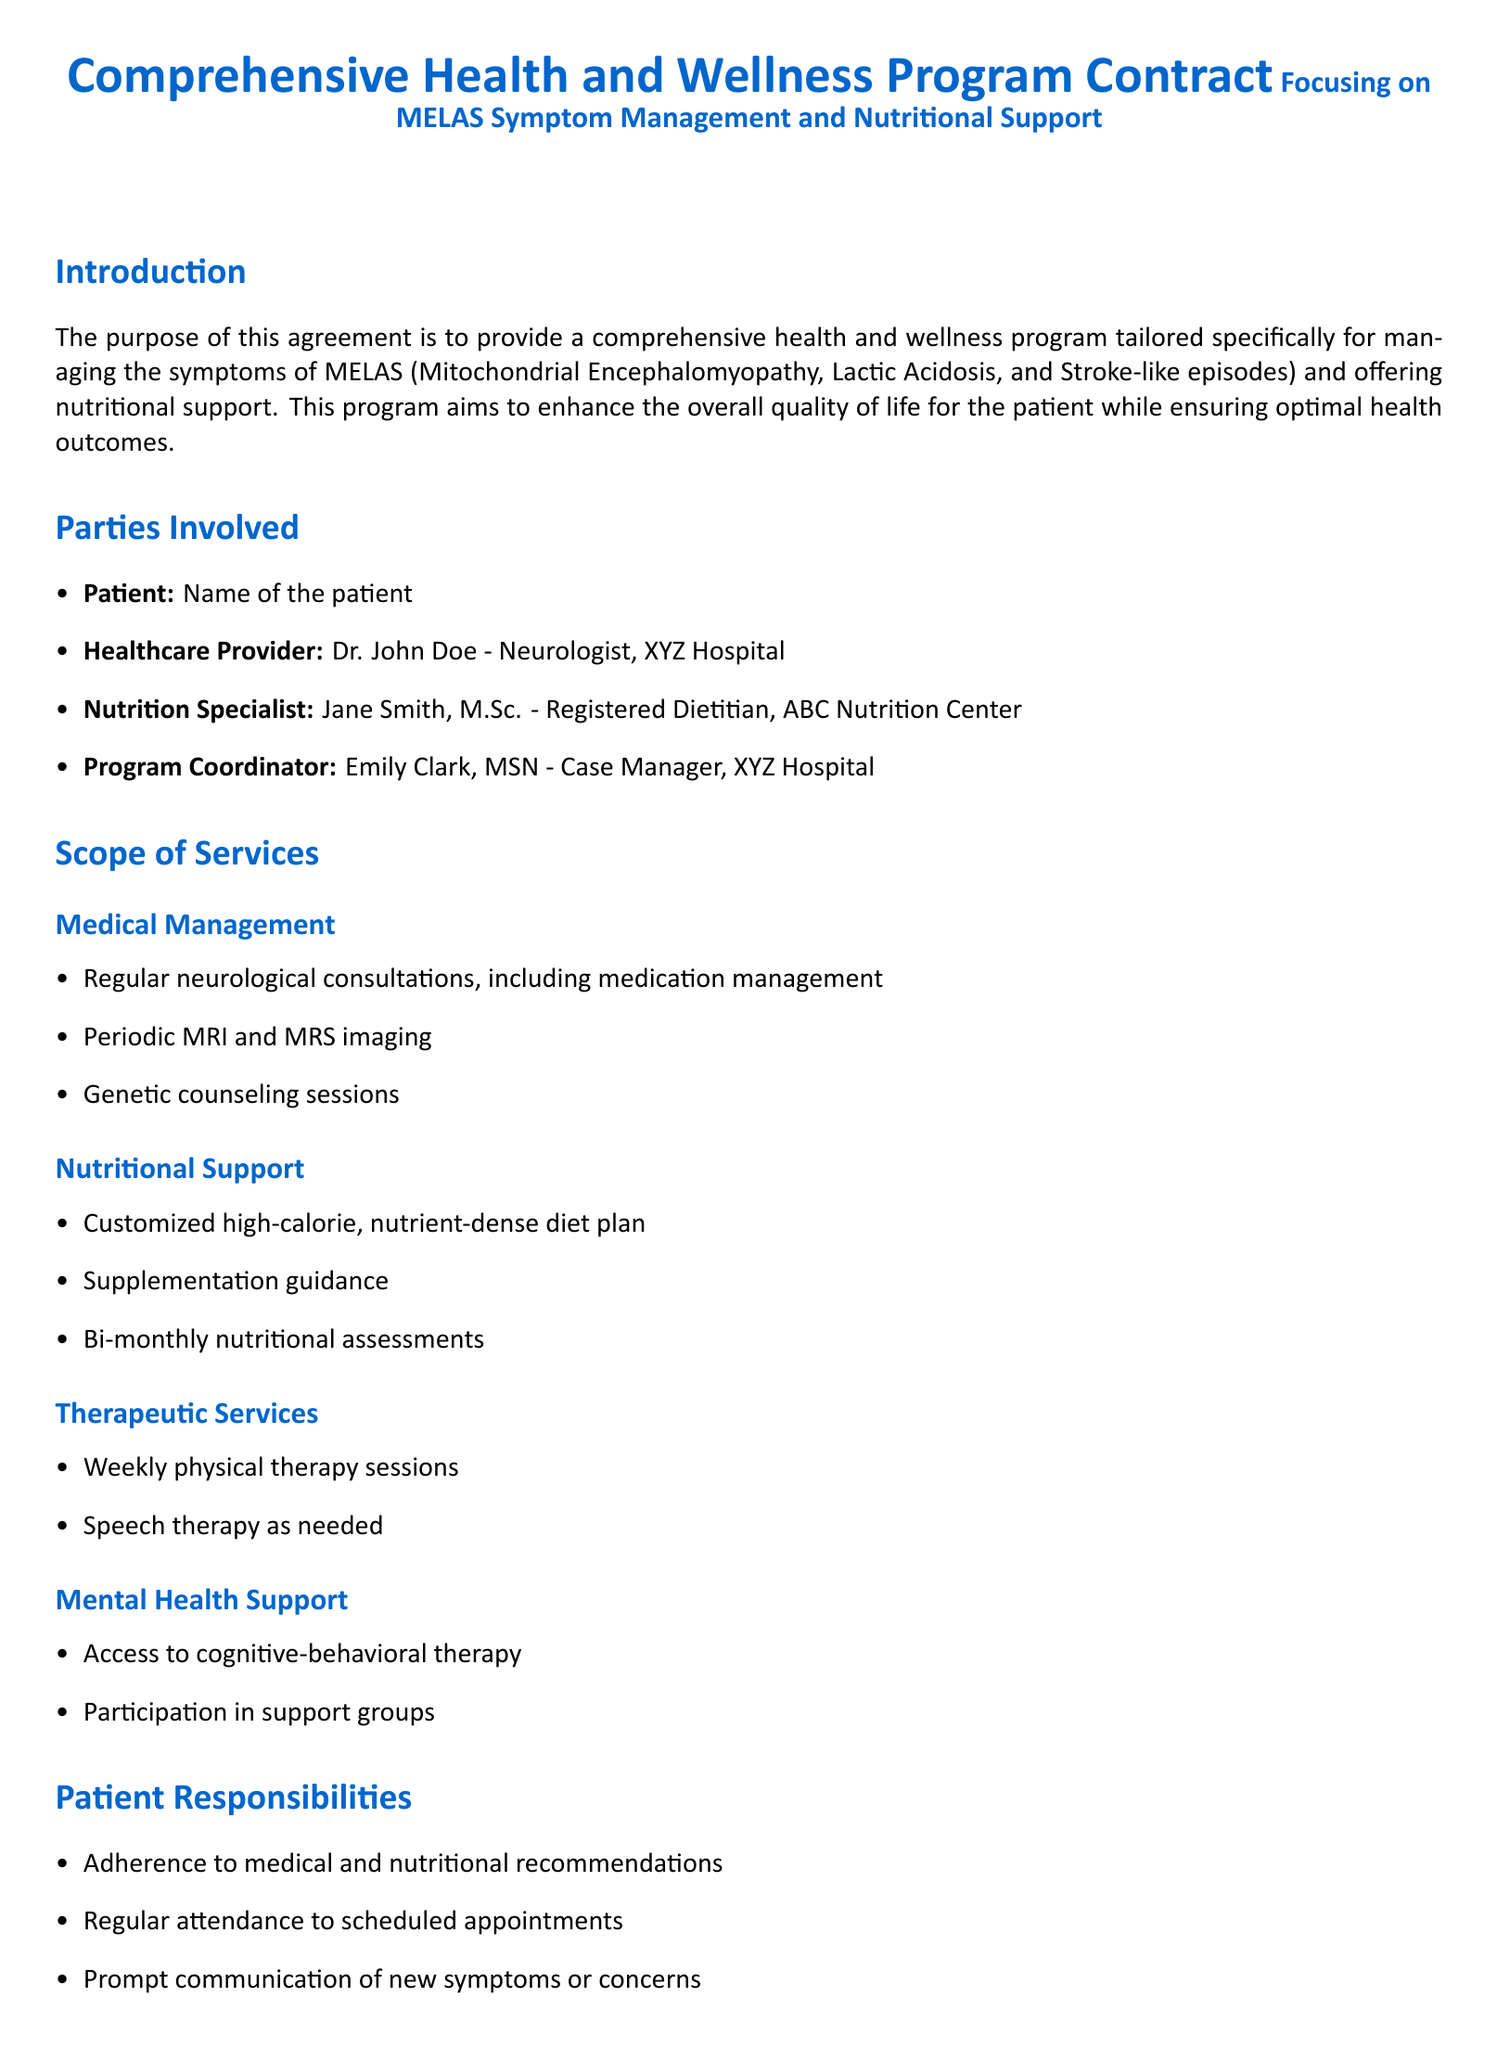What is the start date of the program? The start date is specified in the Duration and Termination section of the document.
Answer: 01-Jan-2024 Who is the Nutrition Specialist? The Nutrition Specialist's name is listed under the Parties Involved section.
Answer: Jane Smith, M.Sc What type of diet plan is included in the nutritional support? This information is found in the Nutritional Support subsection under the Scope of Services.
Answer: Customized high-calorie, nutrient-dense diet plan How often will bi-monthly nutritional assessments occur? The term "bi-monthly" indicates the frequency of assessments in the Nutritional Support section.
Answer: Every two months What is the duration of the contract? The duration is mentioned in the Duration and Termination section of the document.
Answer: 12 months What responsibilities does the patient have? Patient responsibilities are outlined, indicating what is expected of them during the program.
Answer: Adherence to medical and nutritional recommendations Who is responsible for ongoing monitoring? The responsibilities of providers are described in the Provider Responsibilities section.
Answer: Healthcare Provider What type of therapy is offered weekly? This information is located in the Therapeutic Services subsection of the document.
Answer: Physical therapy sessions 